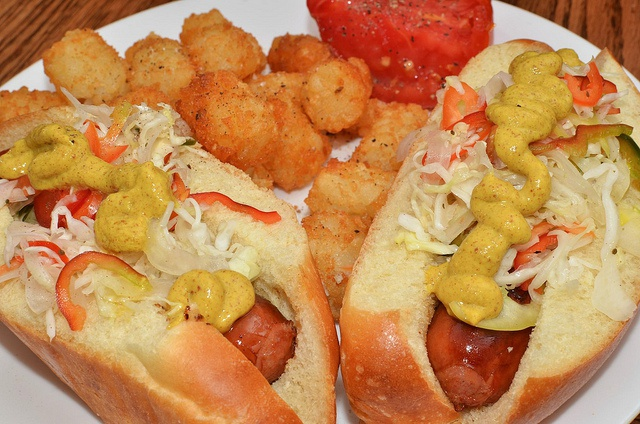Describe the objects in this image and their specific colors. I can see hot dog in maroon, tan, brown, and orange tones and hot dog in maroon, brown, and red tones in this image. 